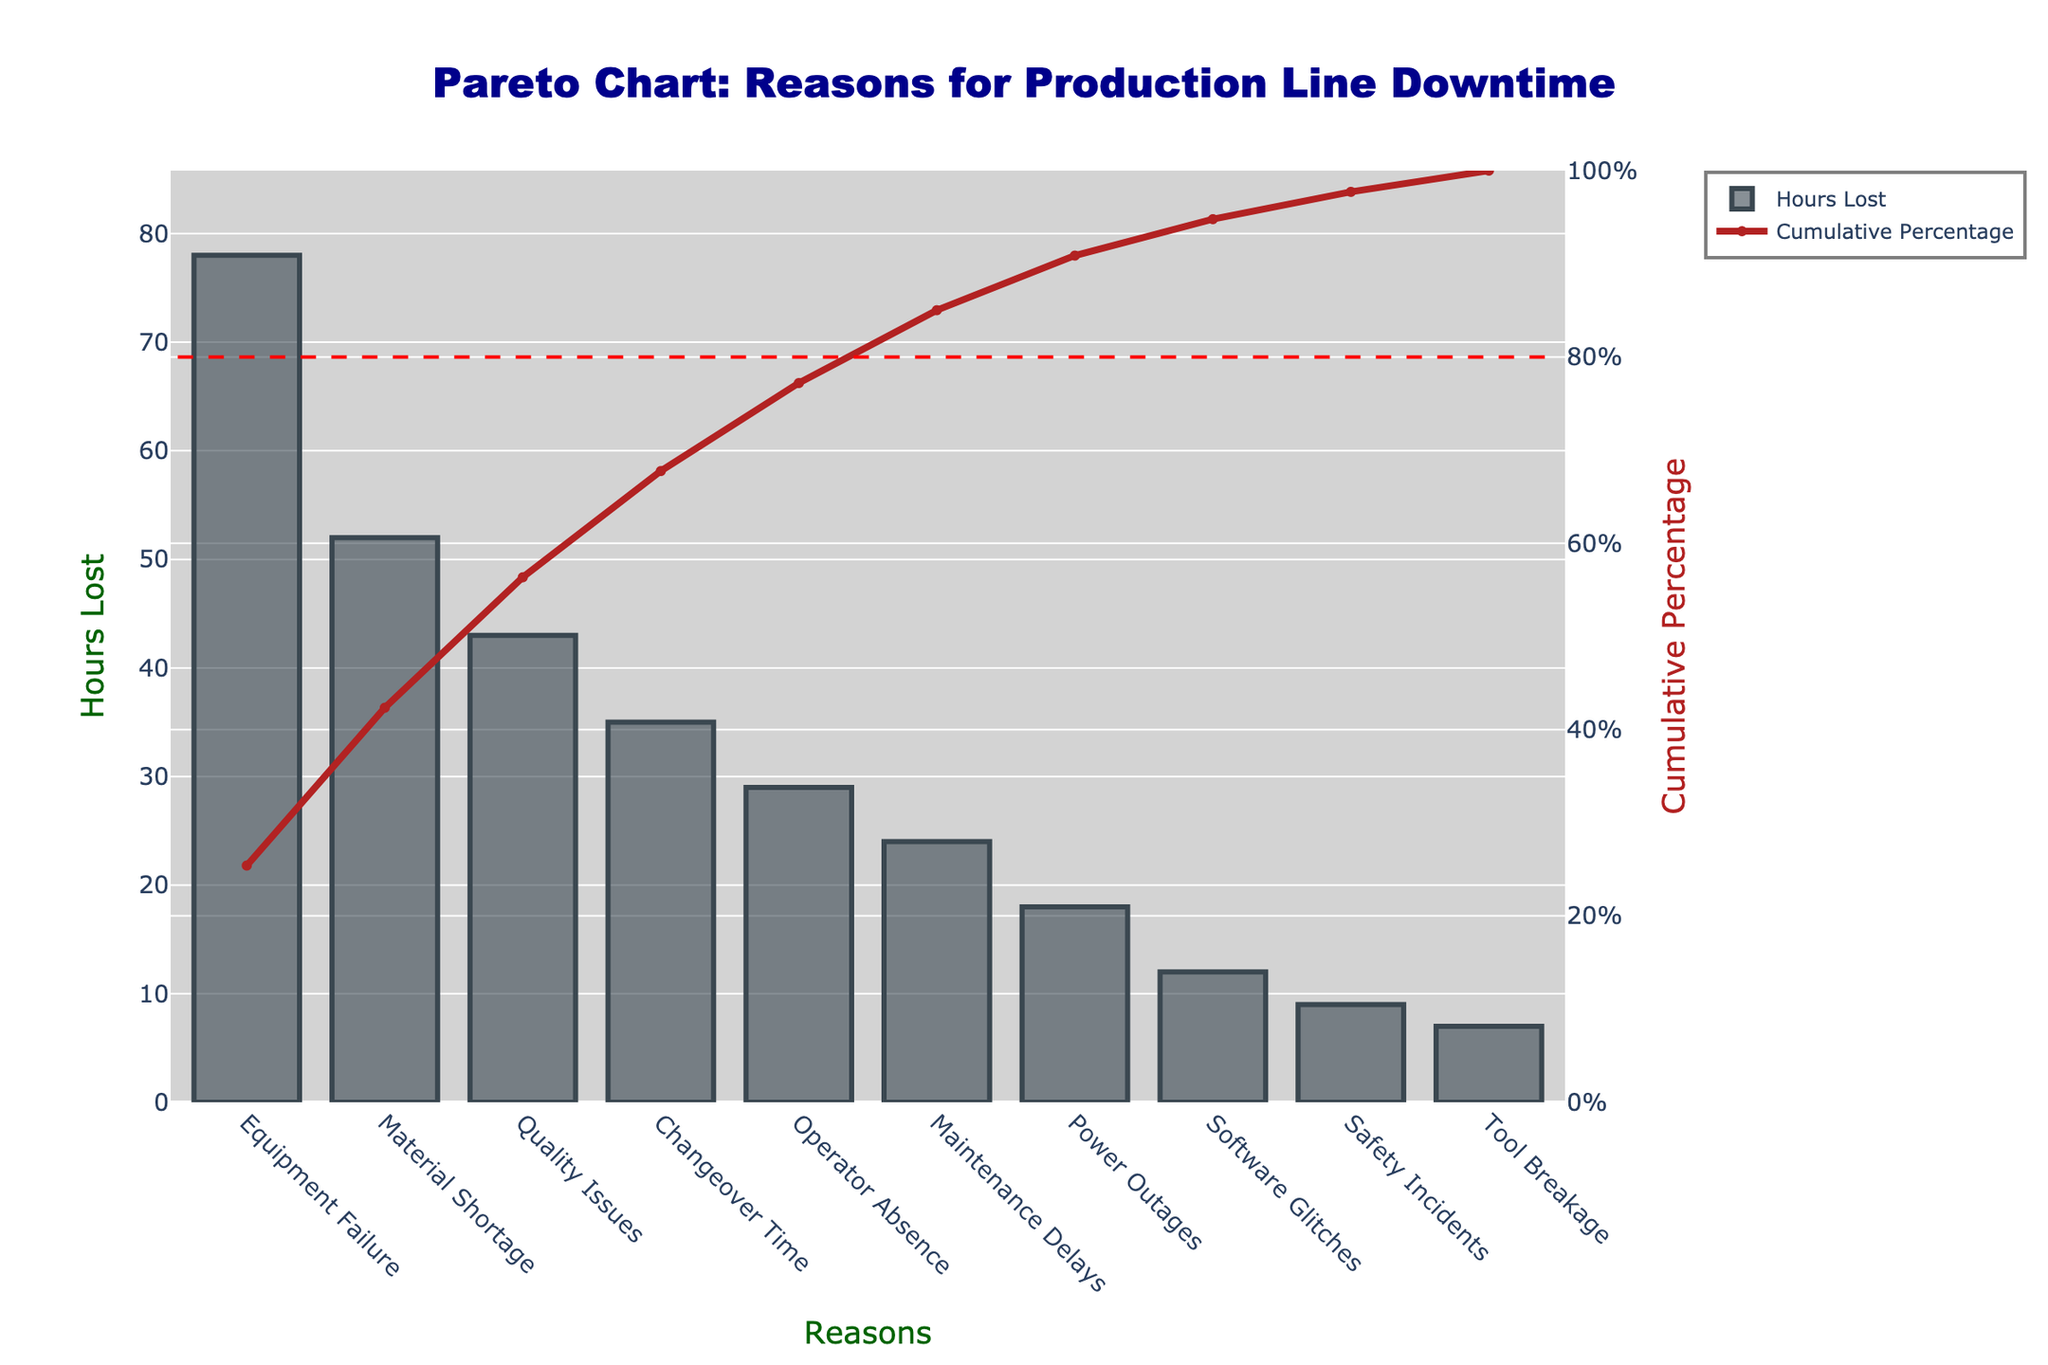What's the title of the chart? The title is located at the top center of the chart and clearly states what the figure represents.
Answer: Pareto Chart: Reasons for Production Line Downtime How many reasons for production line downtime are listed in the chart? Count the number of distinct reasons provided on the x-axis of the bar chart.
Answer: 10 Which reason contributes the most to production line downtime? Identify the bar with the highest value on the y-axis, which corresponds to the reason with the most hours lost.
Answer: Equipment Failure What's the cumulative percentage of downtime from Equipment Failure and Material Shortage combined? Look at the cumulative percentage values for both Equipment Failure and Material Shortage on the y-axis on the right side. Add them together. Equipment Failure is 31.4%, and Material Shortage is 52%. So, 31.4% + 20.9% = 52.3%.
Answer: 52.3% How many total hours are lost due to Changeover Time and Operator Absence combined? Sum the hours lost for both Changeover Time (35) and Operator Absence (29). So, 35 + 29 = 64 hours.
Answer: 64 hours Compare the hours lost due to Quality Issues and Maintenance Delays. Which one is higher and by how much? Subtract the hours lost due to Maintenance Delays from the hours lost due to Quality Issues. Quality Issues: 43 hours, Maintenance Delays: 24 hours. So, 43 - 24 = 19 hours.
Answer: Quality Issues by 19 hours Which downtime reason is closest to the 80-20 line, and what is its cumulative percentage? The 80-20 line is marked at 80% on the cumulative percentage y-axis on the right. Find the cumulative percentage closest to 80%. Changeover Time has a cumulative percentage of 76.3%, which is closest to the 80% line.
Answer: Changeover Time, 76.3% What percentage of the total downtime is caused by the top three reasons? Find the cumulative percentage at the third highest downtime reason, which is Quality Issues at 76.3%.
Answer: 76.3% By how much does the downtime due to Power Outages exceed that due to Safety Incidents? Subtract the hours lost due to Safety Incidents (9) from the hours lost due to Power Outages (18). So, 18 - 9 = 9 hours.
Answer: 9 hours What is the sum of hours lost due to the least three significant reasons in the chart? Sum the hours lost for Tool Breakage (7), Safety Incidents (9), and Software Glitches (12). So, 7 + 9 + 12 = 28 hours.
Answer: 28 hours 